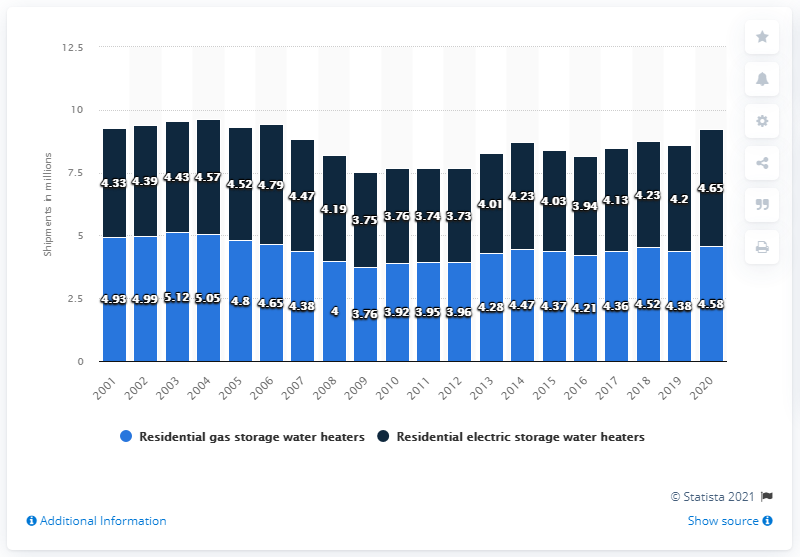List a handful of essential elements in this visual. In 2015, the sum of residential gas storage and electric storage water heaters in the United States was 8.4 million. In 2020, a total of 4,580 residential gas storage water heaters were shipped in the United States. There were approximately 4.58 million residential gas storage water heater shipments in the United States in the year 2020. 